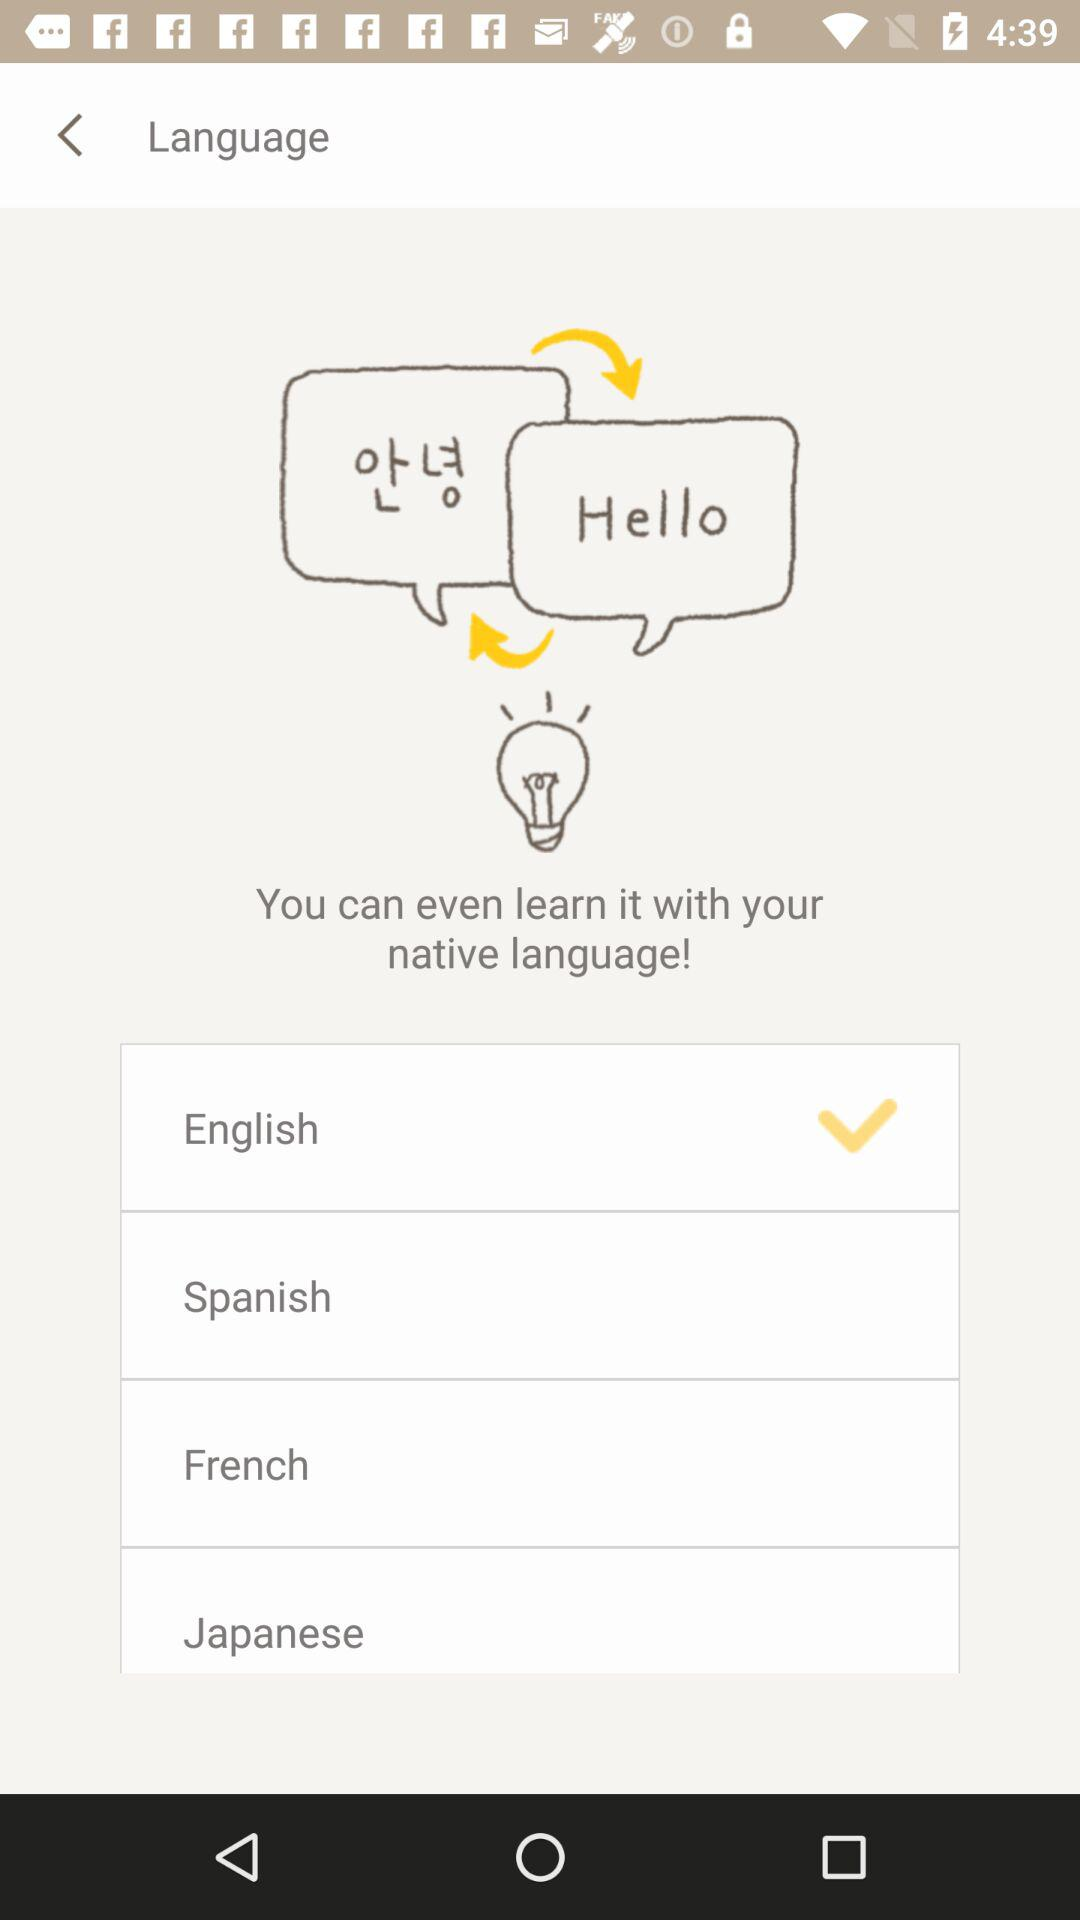How many languages are available for learning?
Answer the question using a single word or phrase. 4 